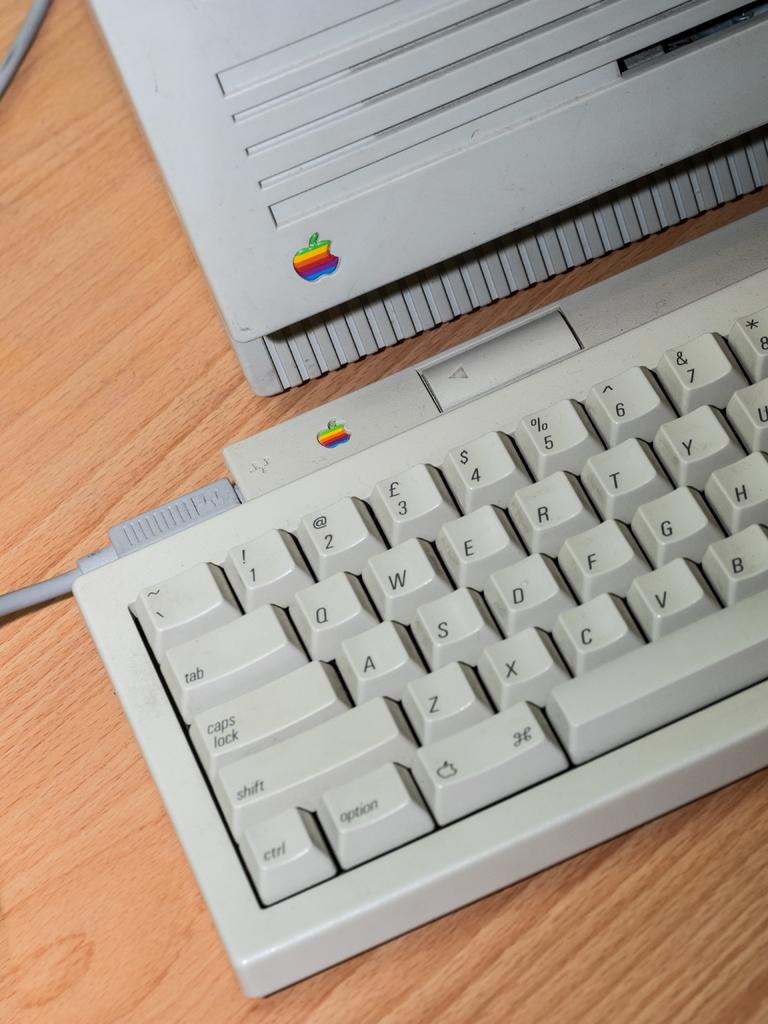Are the keys in qwerty format?
Offer a very short reply. Yes. Who made this keyboard?
Offer a very short reply. Apple. 